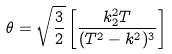<formula> <loc_0><loc_0><loc_500><loc_500>\theta = \sqrt { \frac { 3 } { 2 } } \left [ \frac { k ^ { 2 } _ { 2 } T } { ( T ^ { 2 } - k ^ { 2 } ) ^ { 3 } } \right ]</formula> 